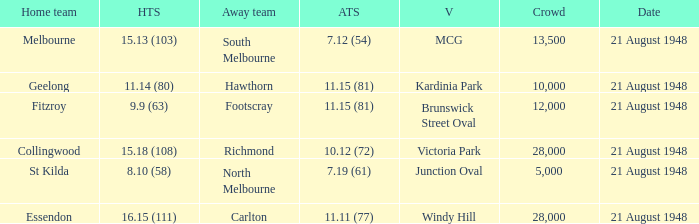If the Crowd is larger than 10,000 and the Away team score is 11.15 (81), what is the venue being played at? Brunswick Street Oval. 